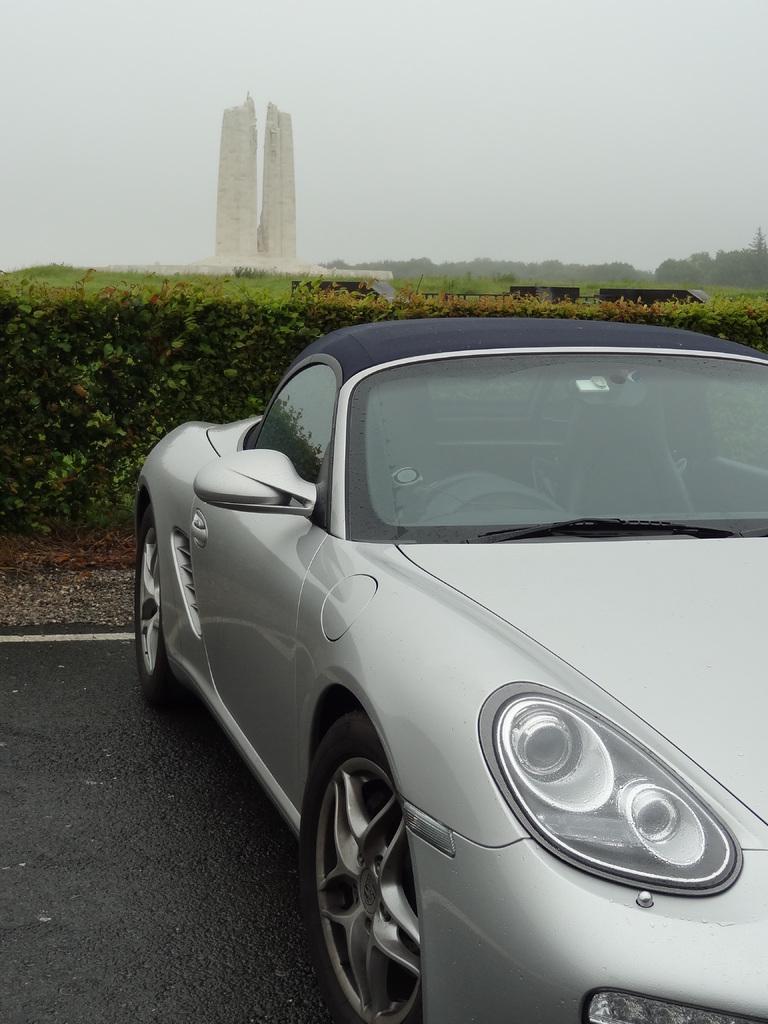Can you describe this image briefly? In the picture there is a car parked on the road and behind the car there are plenty of plants and behind the plants there is a tall stone and beside the stone there are many trees. 